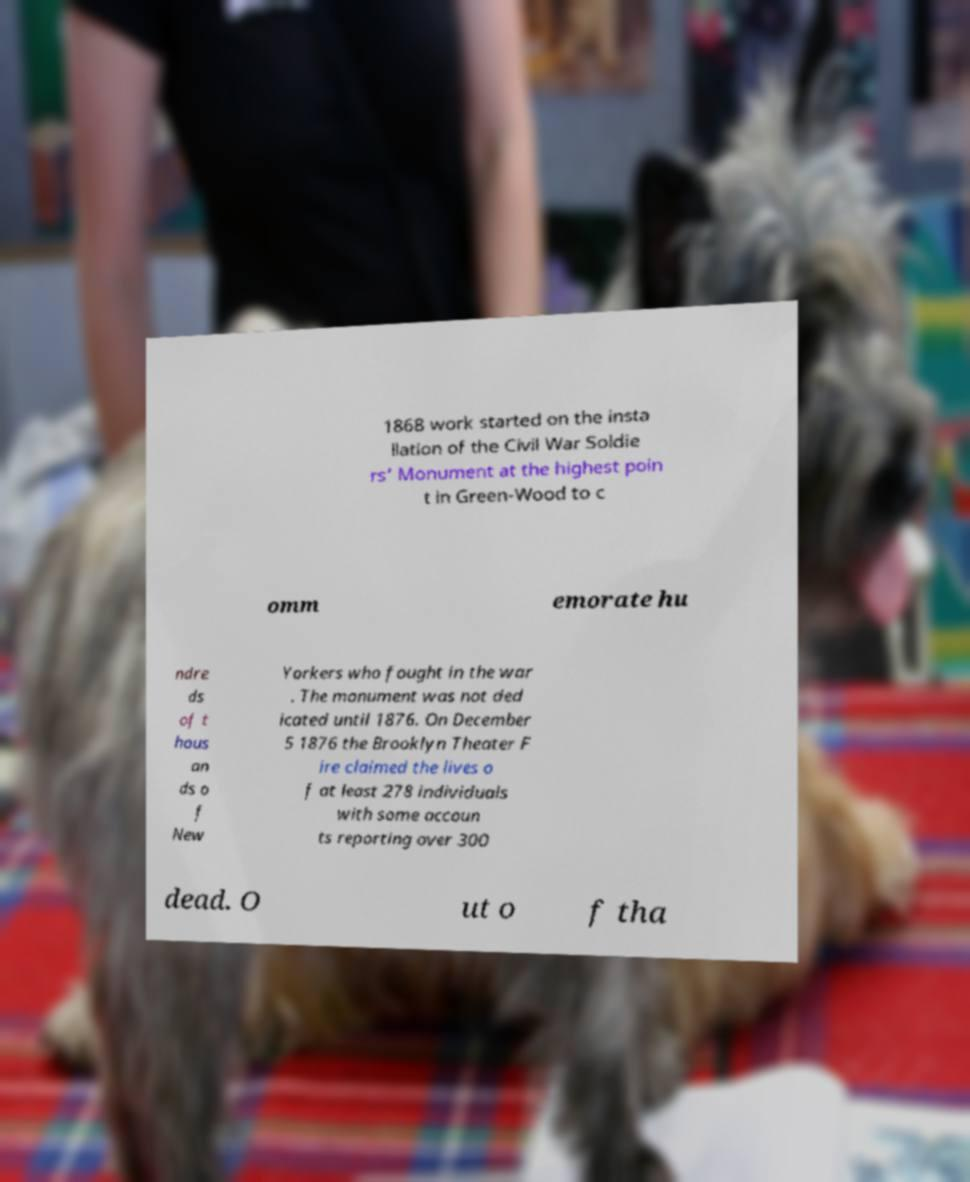Can you read and provide the text displayed in the image?This photo seems to have some interesting text. Can you extract and type it out for me? 1868 work started on the insta llation of the Civil War Soldie rs' Monument at the highest poin t in Green-Wood to c omm emorate hu ndre ds of t hous an ds o f New Yorkers who fought in the war . The monument was not ded icated until 1876. On December 5 1876 the Brooklyn Theater F ire claimed the lives o f at least 278 individuals with some accoun ts reporting over 300 dead. O ut o f tha 